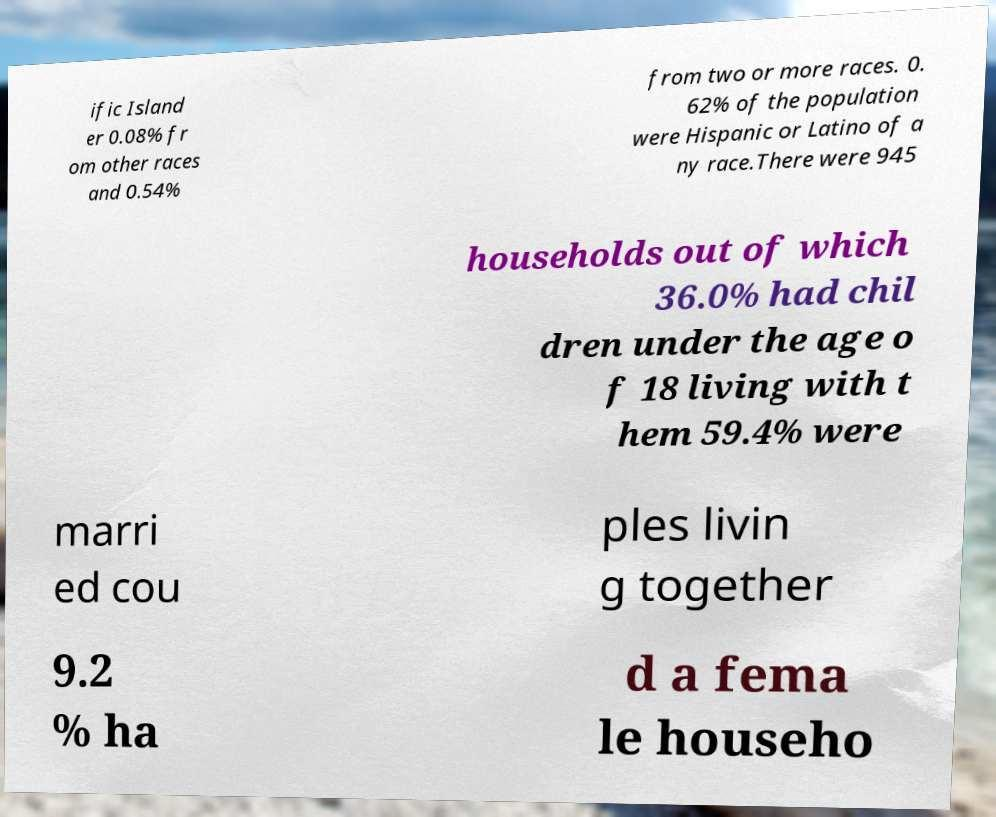There's text embedded in this image that I need extracted. Can you transcribe it verbatim? ific Island er 0.08% fr om other races and 0.54% from two or more races. 0. 62% of the population were Hispanic or Latino of a ny race.There were 945 households out of which 36.0% had chil dren under the age o f 18 living with t hem 59.4% were marri ed cou ples livin g together 9.2 % ha d a fema le househo 